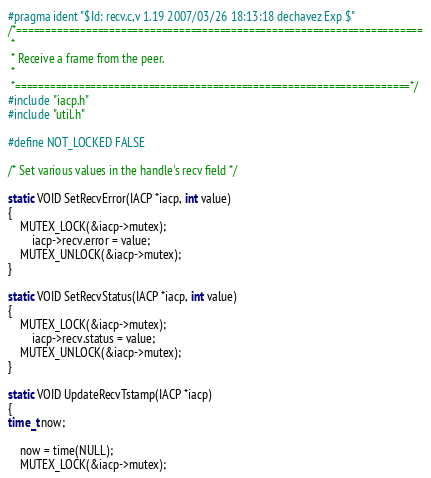<code> <loc_0><loc_0><loc_500><loc_500><_C_>#pragma ident "$Id: recv.c,v 1.19 2007/03/26 18:13:18 dechavez Exp $"
/*======================================================================
 * 
 * Receive a frame from the peer.
 *
 *====================================================================*/
#include "iacp.h"
#include "util.h"

#define NOT_LOCKED FALSE

/* Set various values in the handle's recv field */

static VOID SetRecvError(IACP *iacp, int value)
{
    MUTEX_LOCK(&iacp->mutex);
        iacp->recv.error = value;
    MUTEX_UNLOCK(&iacp->mutex);
}

static VOID SetRecvStatus(IACP *iacp, int value)
{
    MUTEX_LOCK(&iacp->mutex);
        iacp->recv.status = value;
    MUTEX_UNLOCK(&iacp->mutex);
}

static VOID UpdateRecvTstamp(IACP *iacp)
{
time_t now;

    now = time(NULL);
    MUTEX_LOCK(&iacp->mutex);</code> 